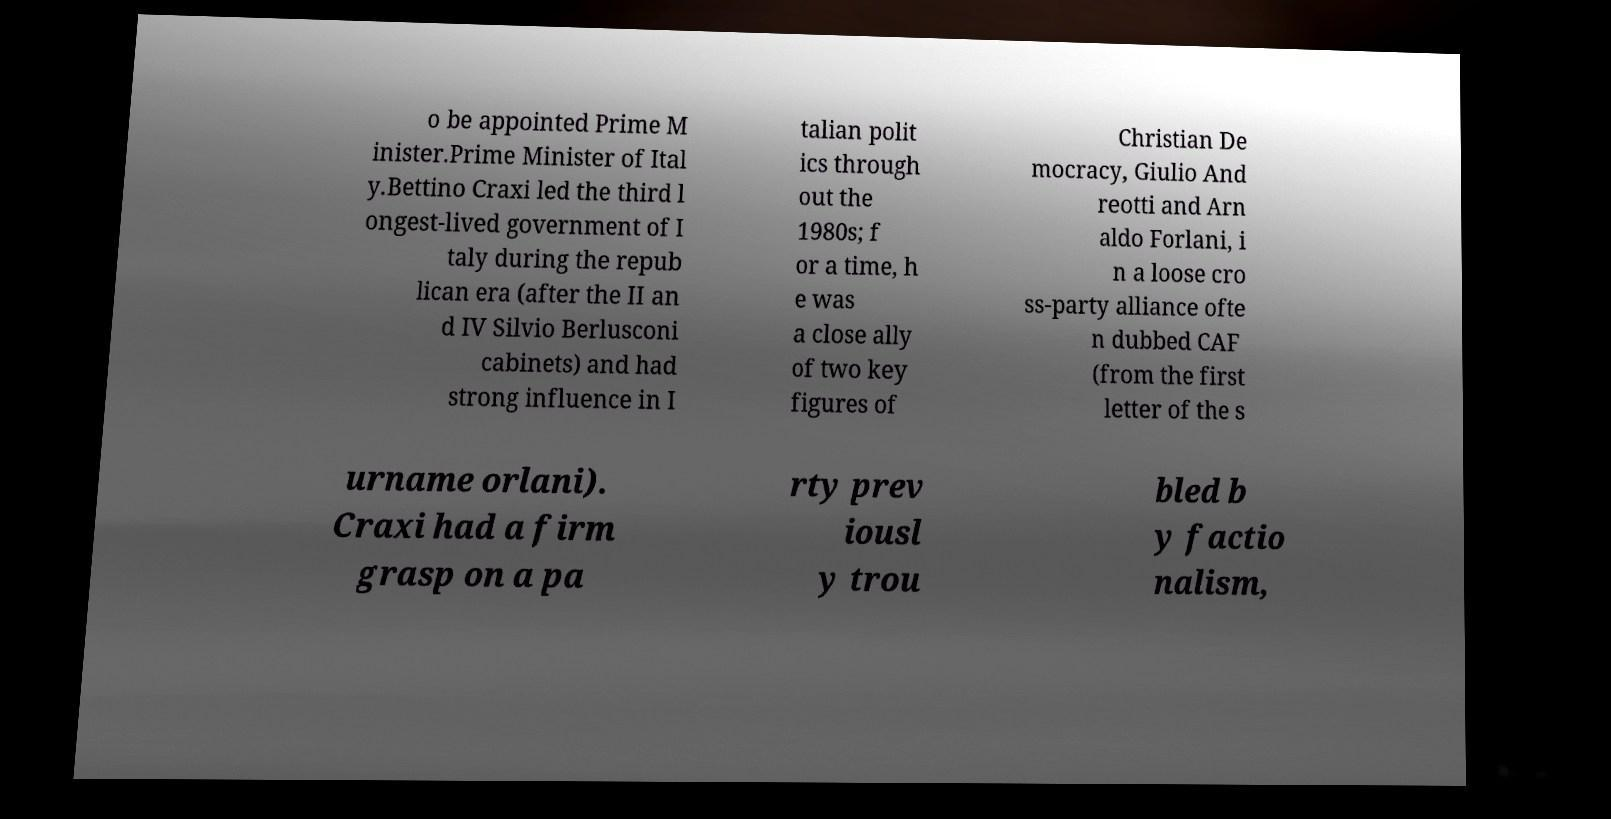Please identify and transcribe the text found in this image. o be appointed Prime M inister.Prime Minister of Ital y.Bettino Craxi led the third l ongest-lived government of I taly during the repub lican era (after the II an d IV Silvio Berlusconi cabinets) and had strong influence in I talian polit ics through out the 1980s; f or a time, h e was a close ally of two key figures of Christian De mocracy, Giulio And reotti and Arn aldo Forlani, i n a loose cro ss-party alliance ofte n dubbed CAF (from the first letter of the s urname orlani). Craxi had a firm grasp on a pa rty prev iousl y trou bled b y factio nalism, 